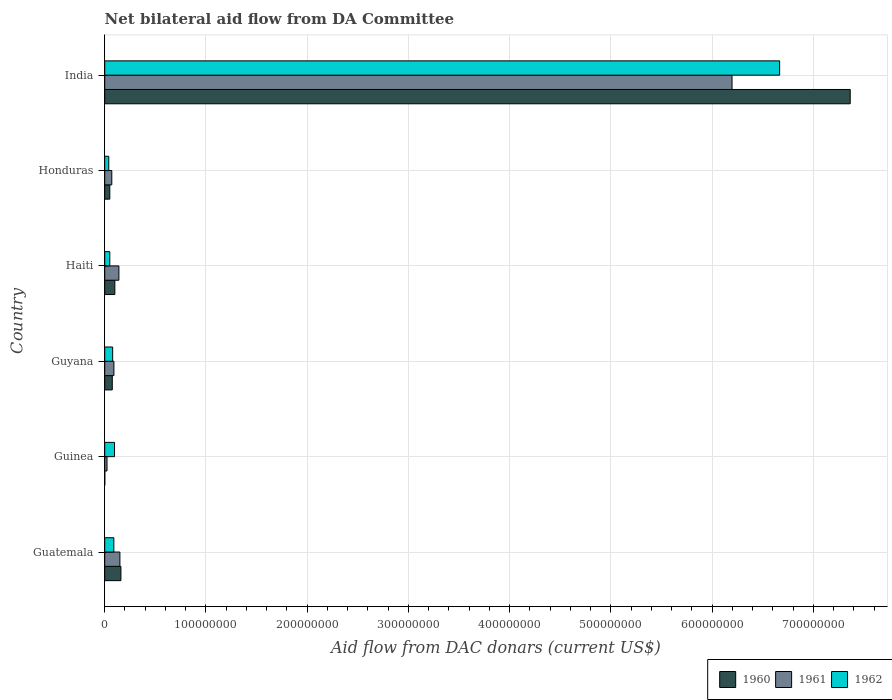How many groups of bars are there?
Your answer should be compact. 6. Are the number of bars on each tick of the Y-axis equal?
Offer a terse response. Yes. How many bars are there on the 4th tick from the top?
Your answer should be compact. 3. How many bars are there on the 6th tick from the bottom?
Provide a succinct answer. 3. What is the label of the 5th group of bars from the top?
Ensure brevity in your answer.  Guinea. In how many cases, is the number of bars for a given country not equal to the number of legend labels?
Make the answer very short. 0. What is the aid flow in in 1962 in Haiti?
Make the answer very short. 5.01e+06. Across all countries, what is the maximum aid flow in in 1960?
Offer a very short reply. 7.36e+08. Across all countries, what is the minimum aid flow in in 1962?
Ensure brevity in your answer.  4.00e+06. In which country was the aid flow in in 1960 minimum?
Your response must be concise. Guinea. What is the total aid flow in in 1961 in the graph?
Offer a terse response. 6.67e+08. What is the difference between the aid flow in in 1962 in Guatemala and that in Guyana?
Your answer should be very brief. 1.17e+06. What is the difference between the aid flow in in 1960 in India and the aid flow in in 1962 in Guinea?
Ensure brevity in your answer.  7.27e+08. What is the average aid flow in in 1962 per country?
Offer a very short reply. 1.17e+08. What is the difference between the aid flow in in 1961 and aid flow in in 1962 in Honduras?
Give a very brief answer. 3.00e+06. In how many countries, is the aid flow in in 1962 greater than 620000000 US$?
Provide a succinct answer. 1. What is the ratio of the aid flow in in 1960 in Guatemala to that in Honduras?
Offer a terse response. 3.2. What is the difference between the highest and the second highest aid flow in in 1960?
Offer a very short reply. 7.20e+08. What is the difference between the highest and the lowest aid flow in in 1962?
Make the answer very short. 6.63e+08. In how many countries, is the aid flow in in 1961 greater than the average aid flow in in 1961 taken over all countries?
Your answer should be compact. 1. What does the 3rd bar from the bottom in Guyana represents?
Offer a very short reply. 1962. How many countries are there in the graph?
Provide a succinct answer. 6. Are the values on the major ticks of X-axis written in scientific E-notation?
Keep it short and to the point. No. Does the graph contain grids?
Your response must be concise. Yes. How many legend labels are there?
Your answer should be compact. 3. How are the legend labels stacked?
Provide a short and direct response. Horizontal. What is the title of the graph?
Offer a terse response. Net bilateral aid flow from DA Committee. Does "1991" appear as one of the legend labels in the graph?
Make the answer very short. No. What is the label or title of the X-axis?
Your answer should be compact. Aid flow from DAC donars (current US$). What is the label or title of the Y-axis?
Ensure brevity in your answer.  Country. What is the Aid flow from DAC donars (current US$) of 1960 in Guatemala?
Ensure brevity in your answer.  1.60e+07. What is the Aid flow from DAC donars (current US$) of 1961 in Guatemala?
Ensure brevity in your answer.  1.50e+07. What is the Aid flow from DAC donars (current US$) in 1962 in Guatemala?
Ensure brevity in your answer.  9.01e+06. What is the Aid flow from DAC donars (current US$) of 1960 in Guinea?
Offer a terse response. 6.00e+04. What is the Aid flow from DAC donars (current US$) in 1961 in Guinea?
Your answer should be very brief. 2.27e+06. What is the Aid flow from DAC donars (current US$) of 1962 in Guinea?
Provide a succinct answer. 9.70e+06. What is the Aid flow from DAC donars (current US$) of 1960 in Guyana?
Your answer should be very brief. 7.47e+06. What is the Aid flow from DAC donars (current US$) in 1961 in Guyana?
Your response must be concise. 9.07e+06. What is the Aid flow from DAC donars (current US$) in 1962 in Guyana?
Give a very brief answer. 7.84e+06. What is the Aid flow from DAC donars (current US$) in 1961 in Haiti?
Your response must be concise. 1.40e+07. What is the Aid flow from DAC donars (current US$) in 1962 in Haiti?
Ensure brevity in your answer.  5.01e+06. What is the Aid flow from DAC donars (current US$) of 1960 in Honduras?
Ensure brevity in your answer.  5.01e+06. What is the Aid flow from DAC donars (current US$) in 1960 in India?
Provide a succinct answer. 7.36e+08. What is the Aid flow from DAC donars (current US$) in 1961 in India?
Your answer should be very brief. 6.20e+08. What is the Aid flow from DAC donars (current US$) of 1962 in India?
Provide a succinct answer. 6.67e+08. Across all countries, what is the maximum Aid flow from DAC donars (current US$) of 1960?
Offer a terse response. 7.36e+08. Across all countries, what is the maximum Aid flow from DAC donars (current US$) in 1961?
Provide a succinct answer. 6.20e+08. Across all countries, what is the maximum Aid flow from DAC donars (current US$) in 1962?
Your answer should be compact. 6.67e+08. Across all countries, what is the minimum Aid flow from DAC donars (current US$) in 1960?
Provide a succinct answer. 6.00e+04. Across all countries, what is the minimum Aid flow from DAC donars (current US$) of 1961?
Your answer should be compact. 2.27e+06. Across all countries, what is the minimum Aid flow from DAC donars (current US$) in 1962?
Your answer should be compact. 4.00e+06. What is the total Aid flow from DAC donars (current US$) of 1960 in the graph?
Offer a very short reply. 7.75e+08. What is the total Aid flow from DAC donars (current US$) of 1961 in the graph?
Keep it short and to the point. 6.67e+08. What is the total Aid flow from DAC donars (current US$) of 1962 in the graph?
Provide a short and direct response. 7.02e+08. What is the difference between the Aid flow from DAC donars (current US$) in 1960 in Guatemala and that in Guinea?
Give a very brief answer. 1.60e+07. What is the difference between the Aid flow from DAC donars (current US$) in 1961 in Guatemala and that in Guinea?
Offer a terse response. 1.27e+07. What is the difference between the Aid flow from DAC donars (current US$) in 1962 in Guatemala and that in Guinea?
Your response must be concise. -6.90e+05. What is the difference between the Aid flow from DAC donars (current US$) in 1960 in Guatemala and that in Guyana?
Your answer should be very brief. 8.54e+06. What is the difference between the Aid flow from DAC donars (current US$) in 1961 in Guatemala and that in Guyana?
Your answer should be very brief. 5.93e+06. What is the difference between the Aid flow from DAC donars (current US$) of 1962 in Guatemala and that in Guyana?
Your answer should be compact. 1.17e+06. What is the difference between the Aid flow from DAC donars (current US$) in 1960 in Guatemala and that in Haiti?
Provide a succinct answer. 6.01e+06. What is the difference between the Aid flow from DAC donars (current US$) of 1960 in Guatemala and that in Honduras?
Provide a short and direct response. 1.10e+07. What is the difference between the Aid flow from DAC donars (current US$) in 1961 in Guatemala and that in Honduras?
Ensure brevity in your answer.  8.00e+06. What is the difference between the Aid flow from DAC donars (current US$) in 1962 in Guatemala and that in Honduras?
Provide a succinct answer. 5.01e+06. What is the difference between the Aid flow from DAC donars (current US$) of 1960 in Guatemala and that in India?
Provide a succinct answer. -7.20e+08. What is the difference between the Aid flow from DAC donars (current US$) in 1961 in Guatemala and that in India?
Give a very brief answer. -6.05e+08. What is the difference between the Aid flow from DAC donars (current US$) in 1962 in Guatemala and that in India?
Offer a terse response. -6.58e+08. What is the difference between the Aid flow from DAC donars (current US$) of 1960 in Guinea and that in Guyana?
Your answer should be compact. -7.41e+06. What is the difference between the Aid flow from DAC donars (current US$) of 1961 in Guinea and that in Guyana?
Provide a short and direct response. -6.80e+06. What is the difference between the Aid flow from DAC donars (current US$) of 1962 in Guinea and that in Guyana?
Your answer should be very brief. 1.86e+06. What is the difference between the Aid flow from DAC donars (current US$) in 1960 in Guinea and that in Haiti?
Ensure brevity in your answer.  -9.94e+06. What is the difference between the Aid flow from DAC donars (current US$) in 1961 in Guinea and that in Haiti?
Make the answer very short. -1.17e+07. What is the difference between the Aid flow from DAC donars (current US$) of 1962 in Guinea and that in Haiti?
Ensure brevity in your answer.  4.69e+06. What is the difference between the Aid flow from DAC donars (current US$) of 1960 in Guinea and that in Honduras?
Make the answer very short. -4.95e+06. What is the difference between the Aid flow from DAC donars (current US$) in 1961 in Guinea and that in Honduras?
Make the answer very short. -4.73e+06. What is the difference between the Aid flow from DAC donars (current US$) of 1962 in Guinea and that in Honduras?
Provide a short and direct response. 5.70e+06. What is the difference between the Aid flow from DAC donars (current US$) in 1960 in Guinea and that in India?
Your answer should be compact. -7.36e+08. What is the difference between the Aid flow from DAC donars (current US$) in 1961 in Guinea and that in India?
Provide a short and direct response. -6.17e+08. What is the difference between the Aid flow from DAC donars (current US$) in 1962 in Guinea and that in India?
Give a very brief answer. -6.57e+08. What is the difference between the Aid flow from DAC donars (current US$) in 1960 in Guyana and that in Haiti?
Provide a succinct answer. -2.53e+06. What is the difference between the Aid flow from DAC donars (current US$) of 1961 in Guyana and that in Haiti?
Offer a terse response. -4.93e+06. What is the difference between the Aid flow from DAC donars (current US$) of 1962 in Guyana and that in Haiti?
Provide a succinct answer. 2.83e+06. What is the difference between the Aid flow from DAC donars (current US$) in 1960 in Guyana and that in Honduras?
Offer a terse response. 2.46e+06. What is the difference between the Aid flow from DAC donars (current US$) in 1961 in Guyana and that in Honduras?
Provide a short and direct response. 2.07e+06. What is the difference between the Aid flow from DAC donars (current US$) in 1962 in Guyana and that in Honduras?
Your answer should be very brief. 3.84e+06. What is the difference between the Aid flow from DAC donars (current US$) of 1960 in Guyana and that in India?
Provide a succinct answer. -7.29e+08. What is the difference between the Aid flow from DAC donars (current US$) of 1961 in Guyana and that in India?
Offer a very short reply. -6.11e+08. What is the difference between the Aid flow from DAC donars (current US$) in 1962 in Guyana and that in India?
Make the answer very short. -6.59e+08. What is the difference between the Aid flow from DAC donars (current US$) of 1960 in Haiti and that in Honduras?
Ensure brevity in your answer.  4.99e+06. What is the difference between the Aid flow from DAC donars (current US$) in 1962 in Haiti and that in Honduras?
Provide a short and direct response. 1.01e+06. What is the difference between the Aid flow from DAC donars (current US$) of 1960 in Haiti and that in India?
Keep it short and to the point. -7.26e+08. What is the difference between the Aid flow from DAC donars (current US$) in 1961 in Haiti and that in India?
Make the answer very short. -6.06e+08. What is the difference between the Aid flow from DAC donars (current US$) in 1962 in Haiti and that in India?
Your answer should be compact. -6.62e+08. What is the difference between the Aid flow from DAC donars (current US$) in 1960 in Honduras and that in India?
Your answer should be compact. -7.31e+08. What is the difference between the Aid flow from DAC donars (current US$) of 1961 in Honduras and that in India?
Give a very brief answer. -6.13e+08. What is the difference between the Aid flow from DAC donars (current US$) in 1962 in Honduras and that in India?
Make the answer very short. -6.63e+08. What is the difference between the Aid flow from DAC donars (current US$) of 1960 in Guatemala and the Aid flow from DAC donars (current US$) of 1961 in Guinea?
Provide a short and direct response. 1.37e+07. What is the difference between the Aid flow from DAC donars (current US$) of 1960 in Guatemala and the Aid flow from DAC donars (current US$) of 1962 in Guinea?
Your response must be concise. 6.31e+06. What is the difference between the Aid flow from DAC donars (current US$) of 1961 in Guatemala and the Aid flow from DAC donars (current US$) of 1962 in Guinea?
Offer a very short reply. 5.30e+06. What is the difference between the Aid flow from DAC donars (current US$) of 1960 in Guatemala and the Aid flow from DAC donars (current US$) of 1961 in Guyana?
Your answer should be very brief. 6.94e+06. What is the difference between the Aid flow from DAC donars (current US$) in 1960 in Guatemala and the Aid flow from DAC donars (current US$) in 1962 in Guyana?
Ensure brevity in your answer.  8.17e+06. What is the difference between the Aid flow from DAC donars (current US$) of 1961 in Guatemala and the Aid flow from DAC donars (current US$) of 1962 in Guyana?
Give a very brief answer. 7.16e+06. What is the difference between the Aid flow from DAC donars (current US$) in 1960 in Guatemala and the Aid flow from DAC donars (current US$) in 1961 in Haiti?
Your response must be concise. 2.01e+06. What is the difference between the Aid flow from DAC donars (current US$) in 1960 in Guatemala and the Aid flow from DAC donars (current US$) in 1962 in Haiti?
Provide a succinct answer. 1.10e+07. What is the difference between the Aid flow from DAC donars (current US$) in 1961 in Guatemala and the Aid flow from DAC donars (current US$) in 1962 in Haiti?
Make the answer very short. 9.99e+06. What is the difference between the Aid flow from DAC donars (current US$) of 1960 in Guatemala and the Aid flow from DAC donars (current US$) of 1961 in Honduras?
Offer a terse response. 9.01e+06. What is the difference between the Aid flow from DAC donars (current US$) in 1960 in Guatemala and the Aid flow from DAC donars (current US$) in 1962 in Honduras?
Your answer should be very brief. 1.20e+07. What is the difference between the Aid flow from DAC donars (current US$) in 1961 in Guatemala and the Aid flow from DAC donars (current US$) in 1962 in Honduras?
Provide a short and direct response. 1.10e+07. What is the difference between the Aid flow from DAC donars (current US$) of 1960 in Guatemala and the Aid flow from DAC donars (current US$) of 1961 in India?
Give a very brief answer. -6.04e+08. What is the difference between the Aid flow from DAC donars (current US$) of 1960 in Guatemala and the Aid flow from DAC donars (current US$) of 1962 in India?
Ensure brevity in your answer.  -6.51e+08. What is the difference between the Aid flow from DAC donars (current US$) in 1961 in Guatemala and the Aid flow from DAC donars (current US$) in 1962 in India?
Make the answer very short. -6.52e+08. What is the difference between the Aid flow from DAC donars (current US$) of 1960 in Guinea and the Aid flow from DAC donars (current US$) of 1961 in Guyana?
Offer a terse response. -9.01e+06. What is the difference between the Aid flow from DAC donars (current US$) in 1960 in Guinea and the Aid flow from DAC donars (current US$) in 1962 in Guyana?
Provide a short and direct response. -7.78e+06. What is the difference between the Aid flow from DAC donars (current US$) in 1961 in Guinea and the Aid flow from DAC donars (current US$) in 1962 in Guyana?
Give a very brief answer. -5.57e+06. What is the difference between the Aid flow from DAC donars (current US$) in 1960 in Guinea and the Aid flow from DAC donars (current US$) in 1961 in Haiti?
Offer a terse response. -1.39e+07. What is the difference between the Aid flow from DAC donars (current US$) of 1960 in Guinea and the Aid flow from DAC donars (current US$) of 1962 in Haiti?
Your answer should be compact. -4.95e+06. What is the difference between the Aid flow from DAC donars (current US$) in 1961 in Guinea and the Aid flow from DAC donars (current US$) in 1962 in Haiti?
Provide a short and direct response. -2.74e+06. What is the difference between the Aid flow from DAC donars (current US$) of 1960 in Guinea and the Aid flow from DAC donars (current US$) of 1961 in Honduras?
Your response must be concise. -6.94e+06. What is the difference between the Aid flow from DAC donars (current US$) in 1960 in Guinea and the Aid flow from DAC donars (current US$) in 1962 in Honduras?
Provide a short and direct response. -3.94e+06. What is the difference between the Aid flow from DAC donars (current US$) of 1961 in Guinea and the Aid flow from DAC donars (current US$) of 1962 in Honduras?
Your answer should be compact. -1.73e+06. What is the difference between the Aid flow from DAC donars (current US$) of 1960 in Guinea and the Aid flow from DAC donars (current US$) of 1961 in India?
Your response must be concise. -6.20e+08. What is the difference between the Aid flow from DAC donars (current US$) of 1960 in Guinea and the Aid flow from DAC donars (current US$) of 1962 in India?
Your answer should be very brief. -6.67e+08. What is the difference between the Aid flow from DAC donars (current US$) in 1961 in Guinea and the Aid flow from DAC donars (current US$) in 1962 in India?
Ensure brevity in your answer.  -6.64e+08. What is the difference between the Aid flow from DAC donars (current US$) of 1960 in Guyana and the Aid flow from DAC donars (current US$) of 1961 in Haiti?
Your answer should be compact. -6.53e+06. What is the difference between the Aid flow from DAC donars (current US$) in 1960 in Guyana and the Aid flow from DAC donars (current US$) in 1962 in Haiti?
Keep it short and to the point. 2.46e+06. What is the difference between the Aid flow from DAC donars (current US$) in 1961 in Guyana and the Aid flow from DAC donars (current US$) in 1962 in Haiti?
Offer a terse response. 4.06e+06. What is the difference between the Aid flow from DAC donars (current US$) in 1960 in Guyana and the Aid flow from DAC donars (current US$) in 1961 in Honduras?
Your answer should be compact. 4.70e+05. What is the difference between the Aid flow from DAC donars (current US$) of 1960 in Guyana and the Aid flow from DAC donars (current US$) of 1962 in Honduras?
Your response must be concise. 3.47e+06. What is the difference between the Aid flow from DAC donars (current US$) of 1961 in Guyana and the Aid flow from DAC donars (current US$) of 1962 in Honduras?
Ensure brevity in your answer.  5.07e+06. What is the difference between the Aid flow from DAC donars (current US$) of 1960 in Guyana and the Aid flow from DAC donars (current US$) of 1961 in India?
Your answer should be very brief. -6.12e+08. What is the difference between the Aid flow from DAC donars (current US$) of 1960 in Guyana and the Aid flow from DAC donars (current US$) of 1962 in India?
Keep it short and to the point. -6.59e+08. What is the difference between the Aid flow from DAC donars (current US$) of 1961 in Guyana and the Aid flow from DAC donars (current US$) of 1962 in India?
Provide a short and direct response. -6.58e+08. What is the difference between the Aid flow from DAC donars (current US$) in 1960 in Haiti and the Aid flow from DAC donars (current US$) in 1961 in Honduras?
Ensure brevity in your answer.  3.00e+06. What is the difference between the Aid flow from DAC donars (current US$) in 1961 in Haiti and the Aid flow from DAC donars (current US$) in 1962 in Honduras?
Provide a succinct answer. 1.00e+07. What is the difference between the Aid flow from DAC donars (current US$) in 1960 in Haiti and the Aid flow from DAC donars (current US$) in 1961 in India?
Your response must be concise. -6.10e+08. What is the difference between the Aid flow from DAC donars (current US$) of 1960 in Haiti and the Aid flow from DAC donars (current US$) of 1962 in India?
Your answer should be very brief. -6.57e+08. What is the difference between the Aid flow from DAC donars (current US$) in 1961 in Haiti and the Aid flow from DAC donars (current US$) in 1962 in India?
Make the answer very short. -6.53e+08. What is the difference between the Aid flow from DAC donars (current US$) of 1960 in Honduras and the Aid flow from DAC donars (current US$) of 1961 in India?
Provide a succinct answer. -6.15e+08. What is the difference between the Aid flow from DAC donars (current US$) in 1960 in Honduras and the Aid flow from DAC donars (current US$) in 1962 in India?
Your answer should be very brief. -6.62e+08. What is the difference between the Aid flow from DAC donars (current US$) of 1961 in Honduras and the Aid flow from DAC donars (current US$) of 1962 in India?
Give a very brief answer. -6.60e+08. What is the average Aid flow from DAC donars (current US$) of 1960 per country?
Offer a terse response. 1.29e+08. What is the average Aid flow from DAC donars (current US$) in 1961 per country?
Your answer should be very brief. 1.11e+08. What is the average Aid flow from DAC donars (current US$) of 1962 per country?
Keep it short and to the point. 1.17e+08. What is the difference between the Aid flow from DAC donars (current US$) in 1960 and Aid flow from DAC donars (current US$) in 1961 in Guatemala?
Provide a succinct answer. 1.01e+06. What is the difference between the Aid flow from DAC donars (current US$) of 1960 and Aid flow from DAC donars (current US$) of 1962 in Guatemala?
Offer a terse response. 7.00e+06. What is the difference between the Aid flow from DAC donars (current US$) of 1961 and Aid flow from DAC donars (current US$) of 1962 in Guatemala?
Give a very brief answer. 5.99e+06. What is the difference between the Aid flow from DAC donars (current US$) of 1960 and Aid flow from DAC donars (current US$) of 1961 in Guinea?
Provide a short and direct response. -2.21e+06. What is the difference between the Aid flow from DAC donars (current US$) in 1960 and Aid flow from DAC donars (current US$) in 1962 in Guinea?
Your answer should be very brief. -9.64e+06. What is the difference between the Aid flow from DAC donars (current US$) of 1961 and Aid flow from DAC donars (current US$) of 1962 in Guinea?
Offer a terse response. -7.43e+06. What is the difference between the Aid flow from DAC donars (current US$) of 1960 and Aid flow from DAC donars (current US$) of 1961 in Guyana?
Ensure brevity in your answer.  -1.60e+06. What is the difference between the Aid flow from DAC donars (current US$) of 1960 and Aid flow from DAC donars (current US$) of 1962 in Guyana?
Give a very brief answer. -3.70e+05. What is the difference between the Aid flow from DAC donars (current US$) of 1961 and Aid flow from DAC donars (current US$) of 1962 in Guyana?
Provide a succinct answer. 1.23e+06. What is the difference between the Aid flow from DAC donars (current US$) of 1960 and Aid flow from DAC donars (current US$) of 1961 in Haiti?
Offer a terse response. -4.00e+06. What is the difference between the Aid flow from DAC donars (current US$) of 1960 and Aid flow from DAC donars (current US$) of 1962 in Haiti?
Ensure brevity in your answer.  4.99e+06. What is the difference between the Aid flow from DAC donars (current US$) of 1961 and Aid flow from DAC donars (current US$) of 1962 in Haiti?
Keep it short and to the point. 8.99e+06. What is the difference between the Aid flow from DAC donars (current US$) of 1960 and Aid flow from DAC donars (current US$) of 1961 in Honduras?
Offer a very short reply. -1.99e+06. What is the difference between the Aid flow from DAC donars (current US$) in 1960 and Aid flow from DAC donars (current US$) in 1962 in Honduras?
Your answer should be very brief. 1.01e+06. What is the difference between the Aid flow from DAC donars (current US$) in 1961 and Aid flow from DAC donars (current US$) in 1962 in Honduras?
Provide a succinct answer. 3.00e+06. What is the difference between the Aid flow from DAC donars (current US$) of 1960 and Aid flow from DAC donars (current US$) of 1961 in India?
Keep it short and to the point. 1.17e+08. What is the difference between the Aid flow from DAC donars (current US$) in 1960 and Aid flow from DAC donars (current US$) in 1962 in India?
Your answer should be compact. 6.97e+07. What is the difference between the Aid flow from DAC donars (current US$) of 1961 and Aid flow from DAC donars (current US$) of 1962 in India?
Provide a short and direct response. -4.70e+07. What is the ratio of the Aid flow from DAC donars (current US$) in 1960 in Guatemala to that in Guinea?
Your answer should be compact. 266.83. What is the ratio of the Aid flow from DAC donars (current US$) of 1961 in Guatemala to that in Guinea?
Provide a succinct answer. 6.61. What is the ratio of the Aid flow from DAC donars (current US$) in 1962 in Guatemala to that in Guinea?
Your answer should be compact. 0.93. What is the ratio of the Aid flow from DAC donars (current US$) in 1960 in Guatemala to that in Guyana?
Your response must be concise. 2.14. What is the ratio of the Aid flow from DAC donars (current US$) of 1961 in Guatemala to that in Guyana?
Keep it short and to the point. 1.65. What is the ratio of the Aid flow from DAC donars (current US$) of 1962 in Guatemala to that in Guyana?
Your answer should be compact. 1.15. What is the ratio of the Aid flow from DAC donars (current US$) of 1960 in Guatemala to that in Haiti?
Give a very brief answer. 1.6. What is the ratio of the Aid flow from DAC donars (current US$) in 1961 in Guatemala to that in Haiti?
Your response must be concise. 1.07. What is the ratio of the Aid flow from DAC donars (current US$) in 1962 in Guatemala to that in Haiti?
Provide a succinct answer. 1.8. What is the ratio of the Aid flow from DAC donars (current US$) in 1960 in Guatemala to that in Honduras?
Your response must be concise. 3.2. What is the ratio of the Aid flow from DAC donars (current US$) in 1961 in Guatemala to that in Honduras?
Your answer should be compact. 2.14. What is the ratio of the Aid flow from DAC donars (current US$) in 1962 in Guatemala to that in Honduras?
Offer a terse response. 2.25. What is the ratio of the Aid flow from DAC donars (current US$) of 1960 in Guatemala to that in India?
Your response must be concise. 0.02. What is the ratio of the Aid flow from DAC donars (current US$) of 1961 in Guatemala to that in India?
Give a very brief answer. 0.02. What is the ratio of the Aid flow from DAC donars (current US$) of 1962 in Guatemala to that in India?
Your answer should be very brief. 0.01. What is the ratio of the Aid flow from DAC donars (current US$) of 1960 in Guinea to that in Guyana?
Your answer should be compact. 0.01. What is the ratio of the Aid flow from DAC donars (current US$) of 1961 in Guinea to that in Guyana?
Ensure brevity in your answer.  0.25. What is the ratio of the Aid flow from DAC donars (current US$) in 1962 in Guinea to that in Guyana?
Your answer should be compact. 1.24. What is the ratio of the Aid flow from DAC donars (current US$) of 1960 in Guinea to that in Haiti?
Offer a very short reply. 0.01. What is the ratio of the Aid flow from DAC donars (current US$) of 1961 in Guinea to that in Haiti?
Keep it short and to the point. 0.16. What is the ratio of the Aid flow from DAC donars (current US$) in 1962 in Guinea to that in Haiti?
Your answer should be compact. 1.94. What is the ratio of the Aid flow from DAC donars (current US$) in 1960 in Guinea to that in Honduras?
Your answer should be very brief. 0.01. What is the ratio of the Aid flow from DAC donars (current US$) in 1961 in Guinea to that in Honduras?
Offer a terse response. 0.32. What is the ratio of the Aid flow from DAC donars (current US$) of 1962 in Guinea to that in Honduras?
Your response must be concise. 2.42. What is the ratio of the Aid flow from DAC donars (current US$) of 1961 in Guinea to that in India?
Ensure brevity in your answer.  0. What is the ratio of the Aid flow from DAC donars (current US$) in 1962 in Guinea to that in India?
Keep it short and to the point. 0.01. What is the ratio of the Aid flow from DAC donars (current US$) in 1960 in Guyana to that in Haiti?
Keep it short and to the point. 0.75. What is the ratio of the Aid flow from DAC donars (current US$) of 1961 in Guyana to that in Haiti?
Give a very brief answer. 0.65. What is the ratio of the Aid flow from DAC donars (current US$) in 1962 in Guyana to that in Haiti?
Offer a terse response. 1.56. What is the ratio of the Aid flow from DAC donars (current US$) in 1960 in Guyana to that in Honduras?
Keep it short and to the point. 1.49. What is the ratio of the Aid flow from DAC donars (current US$) in 1961 in Guyana to that in Honduras?
Your answer should be compact. 1.3. What is the ratio of the Aid flow from DAC donars (current US$) of 1962 in Guyana to that in Honduras?
Offer a terse response. 1.96. What is the ratio of the Aid flow from DAC donars (current US$) in 1960 in Guyana to that in India?
Keep it short and to the point. 0.01. What is the ratio of the Aid flow from DAC donars (current US$) in 1961 in Guyana to that in India?
Offer a terse response. 0.01. What is the ratio of the Aid flow from DAC donars (current US$) in 1962 in Guyana to that in India?
Keep it short and to the point. 0.01. What is the ratio of the Aid flow from DAC donars (current US$) of 1960 in Haiti to that in Honduras?
Your answer should be very brief. 2. What is the ratio of the Aid flow from DAC donars (current US$) of 1962 in Haiti to that in Honduras?
Keep it short and to the point. 1.25. What is the ratio of the Aid flow from DAC donars (current US$) in 1960 in Haiti to that in India?
Your answer should be very brief. 0.01. What is the ratio of the Aid flow from DAC donars (current US$) in 1961 in Haiti to that in India?
Your answer should be very brief. 0.02. What is the ratio of the Aid flow from DAC donars (current US$) in 1962 in Haiti to that in India?
Offer a very short reply. 0.01. What is the ratio of the Aid flow from DAC donars (current US$) in 1960 in Honduras to that in India?
Give a very brief answer. 0.01. What is the ratio of the Aid flow from DAC donars (current US$) in 1961 in Honduras to that in India?
Make the answer very short. 0.01. What is the ratio of the Aid flow from DAC donars (current US$) in 1962 in Honduras to that in India?
Provide a short and direct response. 0.01. What is the difference between the highest and the second highest Aid flow from DAC donars (current US$) of 1960?
Ensure brevity in your answer.  7.20e+08. What is the difference between the highest and the second highest Aid flow from DAC donars (current US$) of 1961?
Offer a very short reply. 6.05e+08. What is the difference between the highest and the second highest Aid flow from DAC donars (current US$) of 1962?
Your response must be concise. 6.57e+08. What is the difference between the highest and the lowest Aid flow from DAC donars (current US$) of 1960?
Provide a short and direct response. 7.36e+08. What is the difference between the highest and the lowest Aid flow from DAC donars (current US$) in 1961?
Your answer should be very brief. 6.17e+08. What is the difference between the highest and the lowest Aid flow from DAC donars (current US$) of 1962?
Make the answer very short. 6.63e+08. 